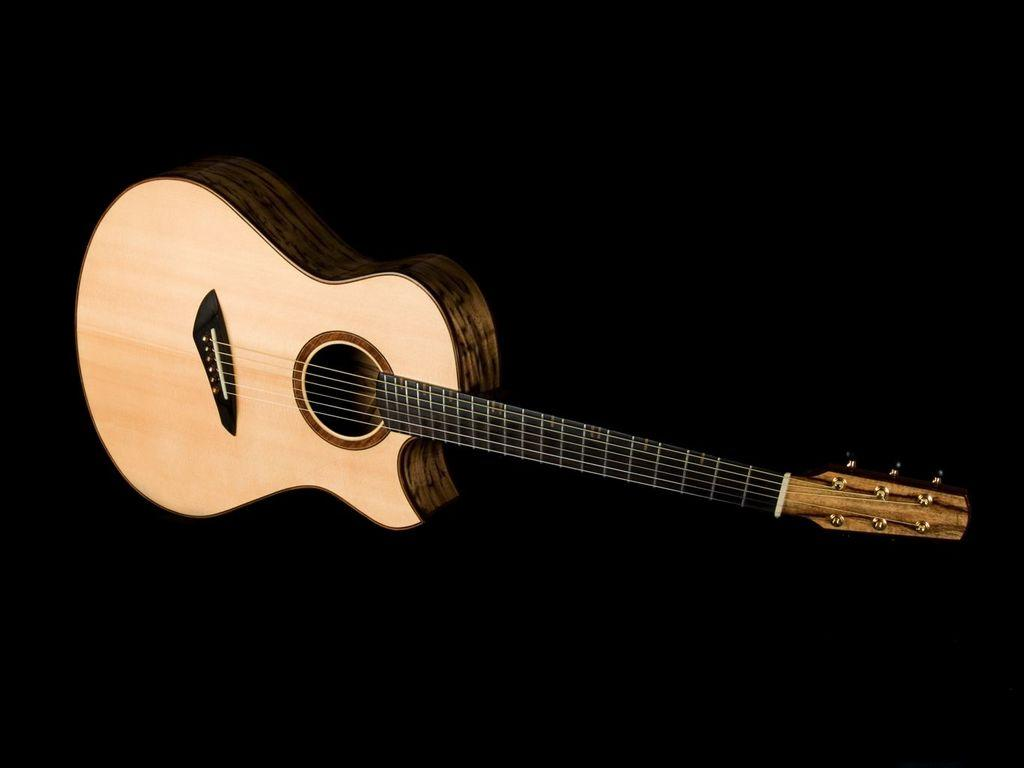What is the main object in the center of the image? There is a guitar in the middle of the image. What might the guitar be used for? The guitar is a musical instrument, so it might be used for playing music. Can you describe the guitar's appearance in the image? The guitar appears to be a standard six-string guitar, with a body, neck, and strings. What type of expansion is visible on the guitar in the image? There is no visible expansion on the guitar in the image. What body part is missing from the guitar in the image? The guitar in the image is a complete instrument and does not have any missing body parts. 